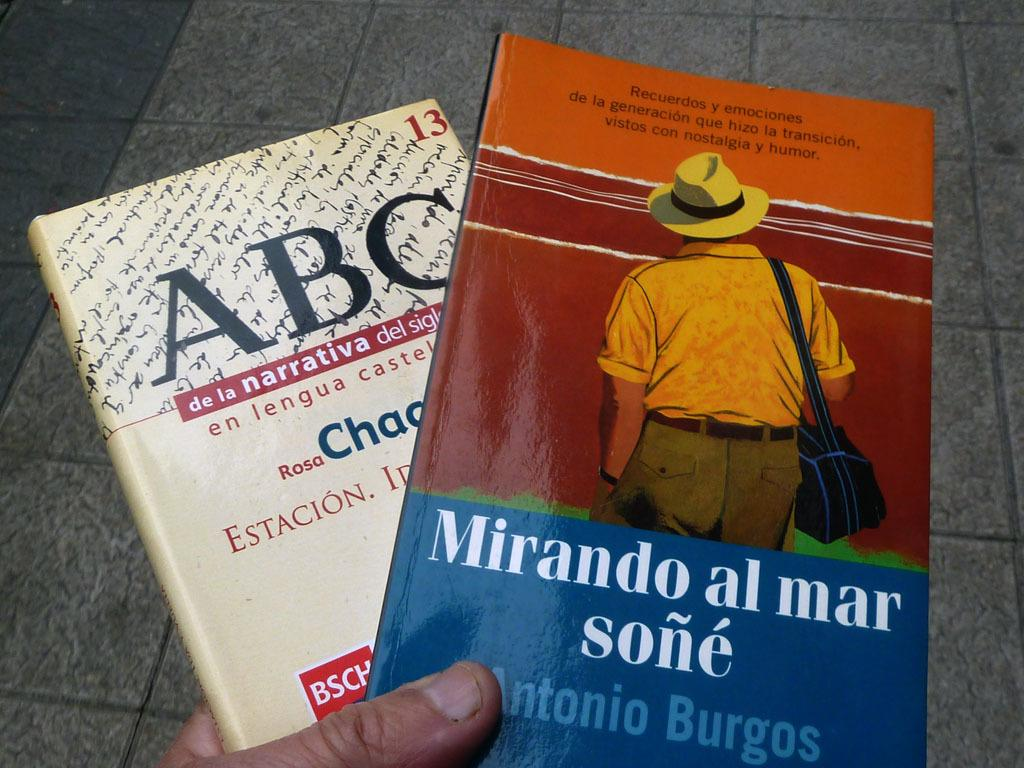<image>
Write a terse but informative summary of the picture. A hand holds two books, one written by Antonio Burgos. 